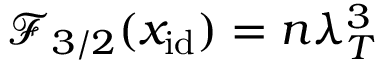Convert formula to latex. <formula><loc_0><loc_0><loc_500><loc_500>\mathcal { F } _ { 3 / 2 } ( x _ { i d } ) = n \lambda _ { T } ^ { 3 }</formula> 